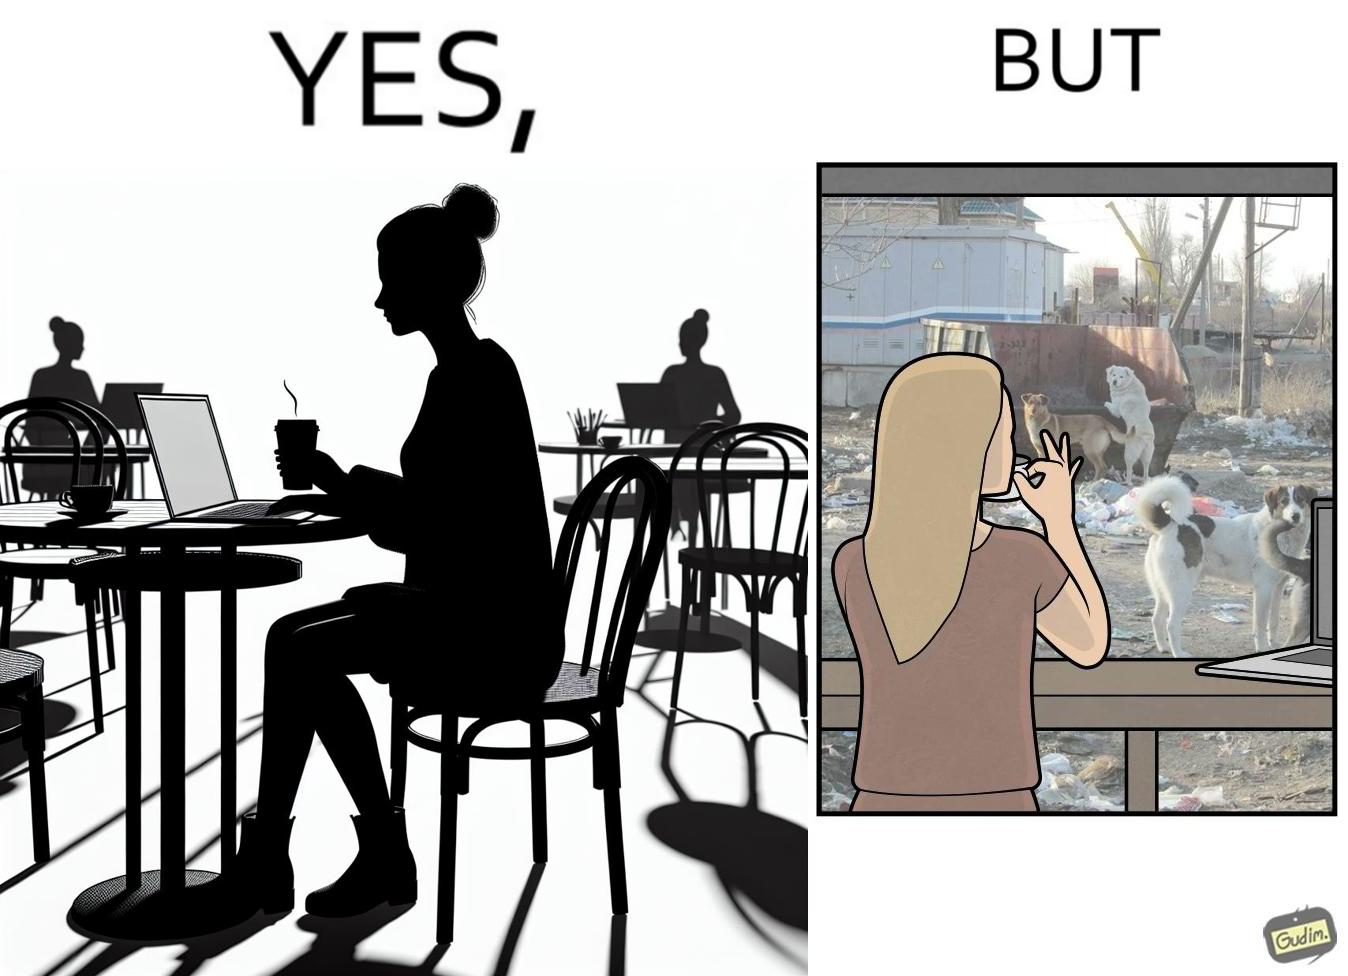What is the satirical meaning behind this image? The people nowadays are not concerned about the surroundings, everyone is busy in their life, like in the image it is shown that even when the woman notices the issues faced by stray but even then she is not ready to raise her voice or do some action for the cause 